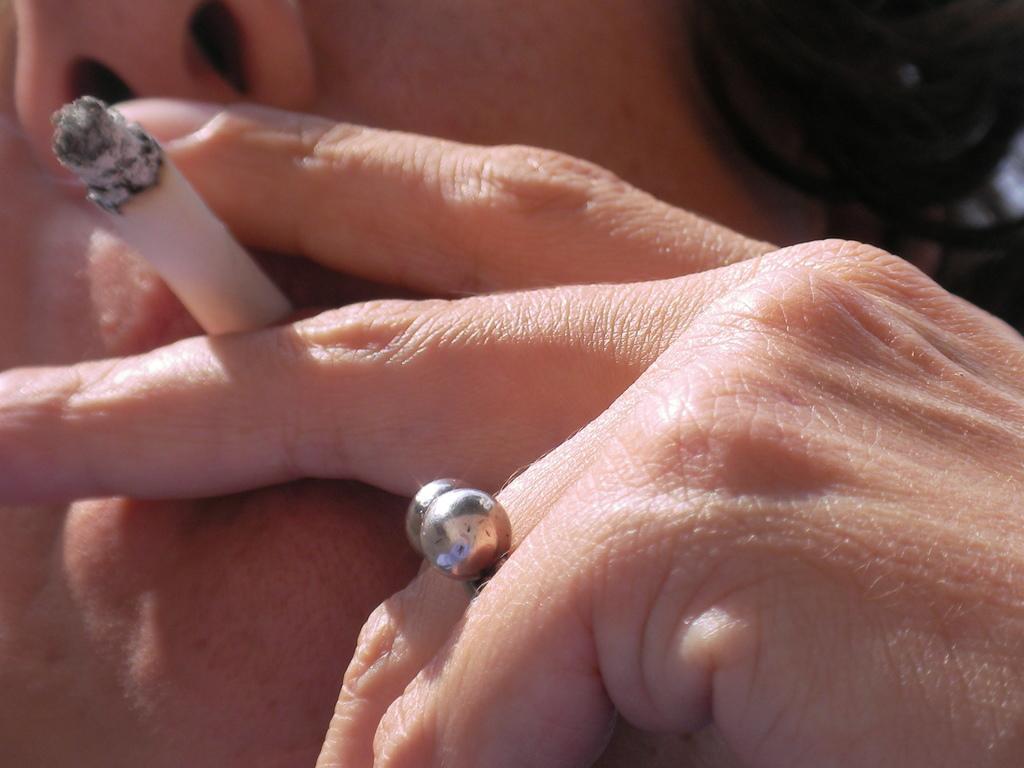How would you summarize this image in a sentence or two? In this image, there is a person holding a cigarette with his fingers. This person is wearing a ring on his finger. 